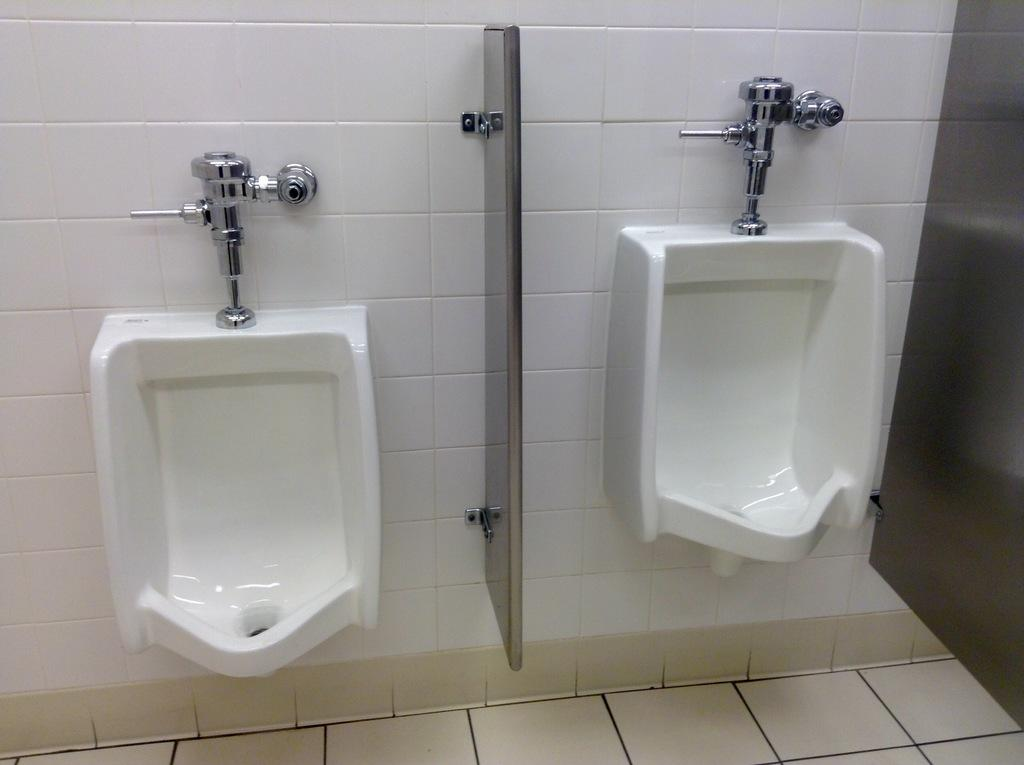How many toilet basins are visible in the image? There are two toilet basins in the image. Where are the toilet basins located? The toilet basins are mounted on the wall. Is there any separation between the two toilet basins? Yes, there is a partition between the two toilet basins. Can you see a lake in the image? No, there is no lake present in the image. Are there any skaters visible in the image? No, there are no skaters present in the image. 